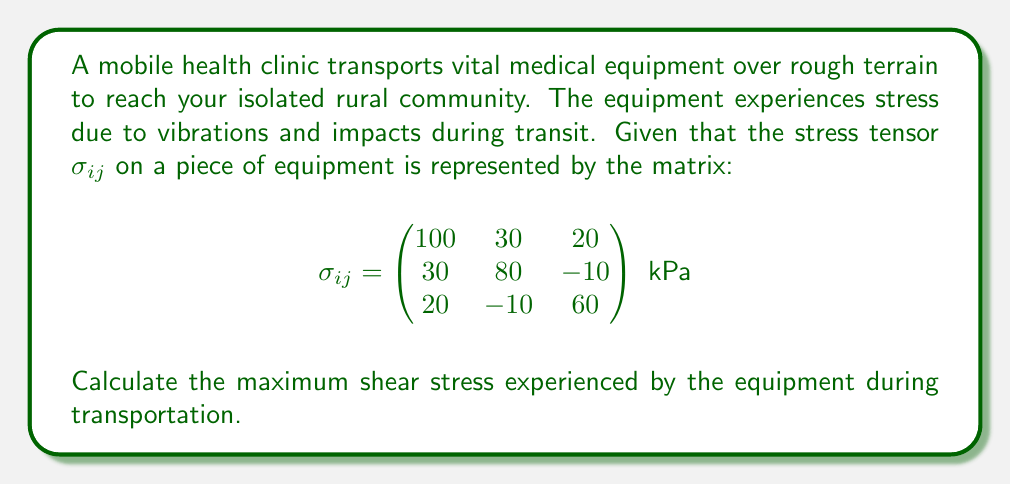Show me your answer to this math problem. To find the maximum shear stress, we need to follow these steps:

1) First, we need to calculate the principal stresses. These are the eigenvalues of the stress tensor matrix.

2) The characteristic equation for the eigenvalues is:
   $$\det(\sigma_{ij} - \lambda I) = 0$$

3) Expanding this determinant:
   $$(100-\lambda)(80-\lambda)(60-\lambda) + 30(-10)(20) + 20(30)(-10) - (100-\lambda)(10)^2 - (80-\lambda)(20)^2 - (60-\lambda)(30)^2 = 0$$

4) Simplifying:
   $$-\lambda^3 + 240\lambda^2 - 17900\lambda + 422000 = 0$$

5) Solving this cubic equation (using a calculator or computer algebra system) gives the principal stresses:
   $$\lambda_1 \approx 118.7 \text{ kPa}$$
   $$\lambda_2 \approx 82.6 \text{ kPa}$$
   $$\lambda_3 \approx 38.7 \text{ kPa}$$

6) The maximum shear stress $\tau_{max}$ is given by:
   $$\tau_{max} = \frac{\lambda_{max} - \lambda_{min}}{2}$$

7) Therefore:
   $$\tau_{max} = \frac{118.7 - 38.7}{2} = 40 \text{ kPa}$$
Answer: $40 \text{ kPa}$ 